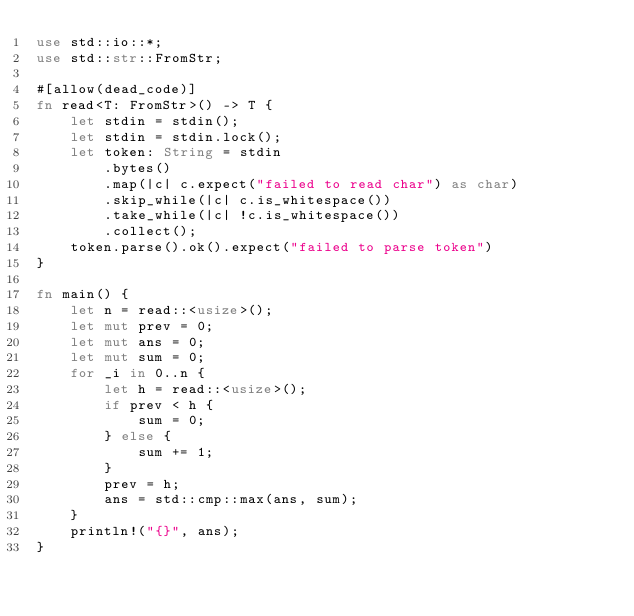<code> <loc_0><loc_0><loc_500><loc_500><_Rust_>use std::io::*;
use std::str::FromStr;

#[allow(dead_code)]
fn read<T: FromStr>() -> T {
    let stdin = stdin();
    let stdin = stdin.lock();
    let token: String = stdin
        .bytes()
        .map(|c| c.expect("failed to read char") as char)
        .skip_while(|c| c.is_whitespace())
        .take_while(|c| !c.is_whitespace())
        .collect();
    token.parse().ok().expect("failed to parse token")
}

fn main() {
    let n = read::<usize>();
    let mut prev = 0;
    let mut ans = 0;
    let mut sum = 0;
    for _i in 0..n {
        let h = read::<usize>();
        if prev < h {
            sum = 0;
        } else {
            sum += 1;
        }
        prev = h;
        ans = std::cmp::max(ans, sum);
    }
    println!("{}", ans);
}
</code> 